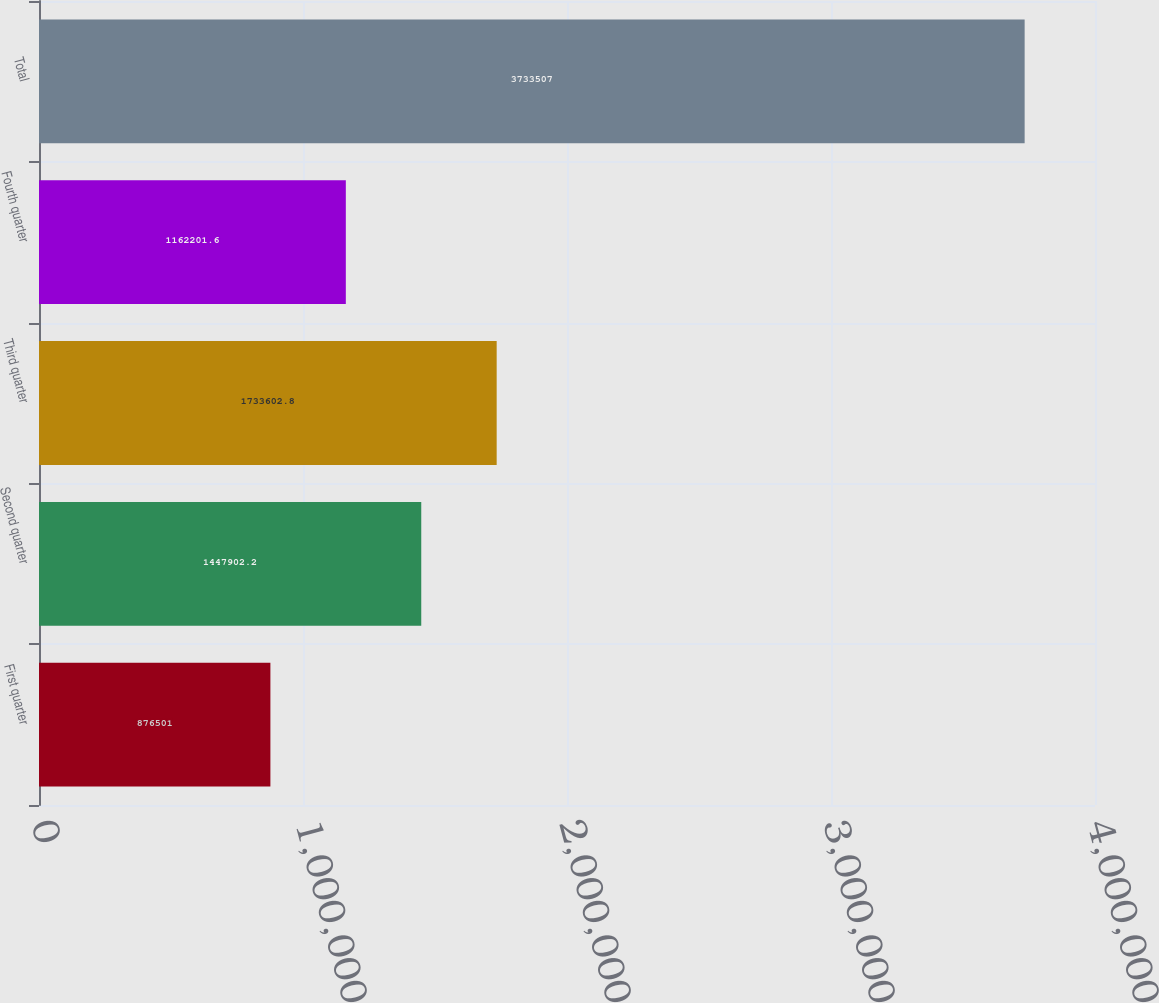<chart> <loc_0><loc_0><loc_500><loc_500><bar_chart><fcel>First quarter<fcel>Second quarter<fcel>Third quarter<fcel>Fourth quarter<fcel>Total<nl><fcel>876501<fcel>1.4479e+06<fcel>1.7336e+06<fcel>1.1622e+06<fcel>3.73351e+06<nl></chart> 